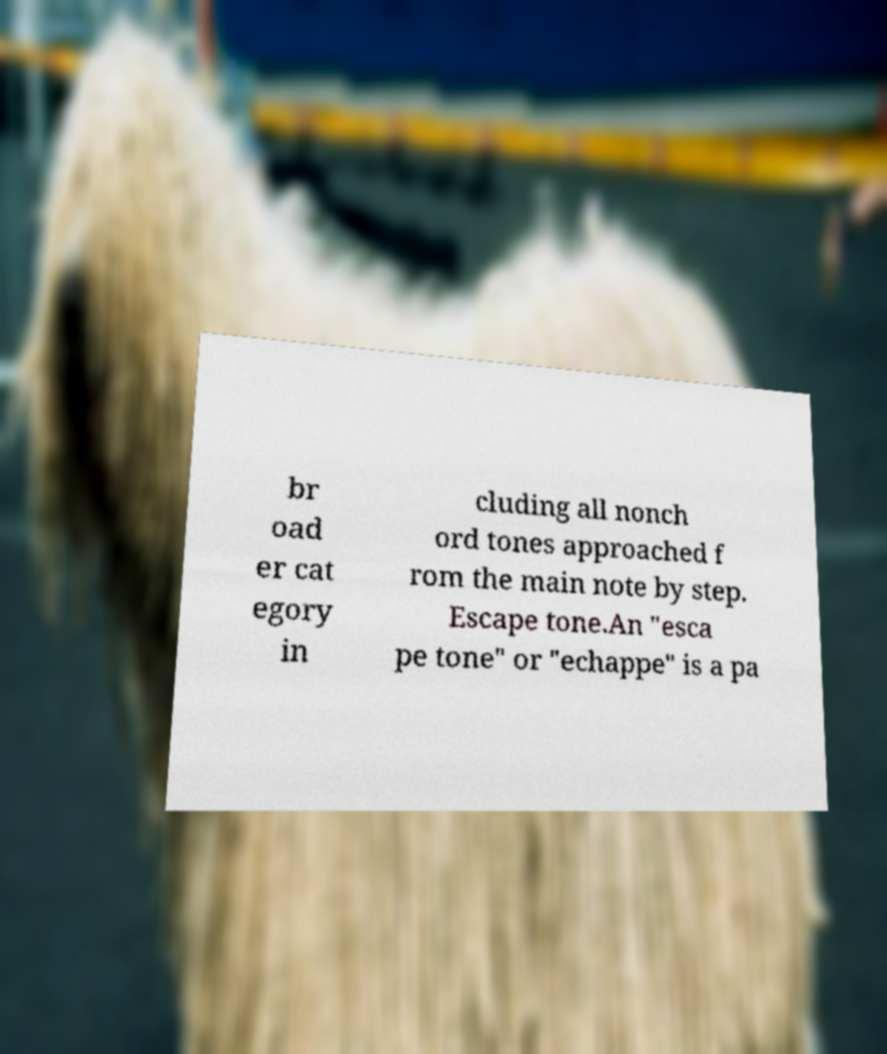Can you read and provide the text displayed in the image?This photo seems to have some interesting text. Can you extract and type it out for me? br oad er cat egory in cluding all nonch ord tones approached f rom the main note by step. Escape tone.An "esca pe tone" or "echappe" is a pa 